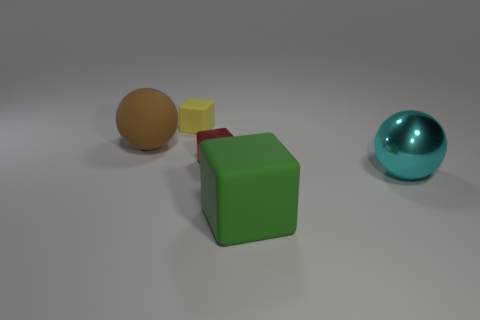There is a large thing that is on the left side of the small yellow matte cube; is its shape the same as the cyan metallic object? The shape of the large object on the left, which appears to be a brown matte sphere, is not the same as the cyan metallic object. The cyan object is a shiny, metallic sphere, which means the two objects differ both in color and material, but they both are spherical in shape. 